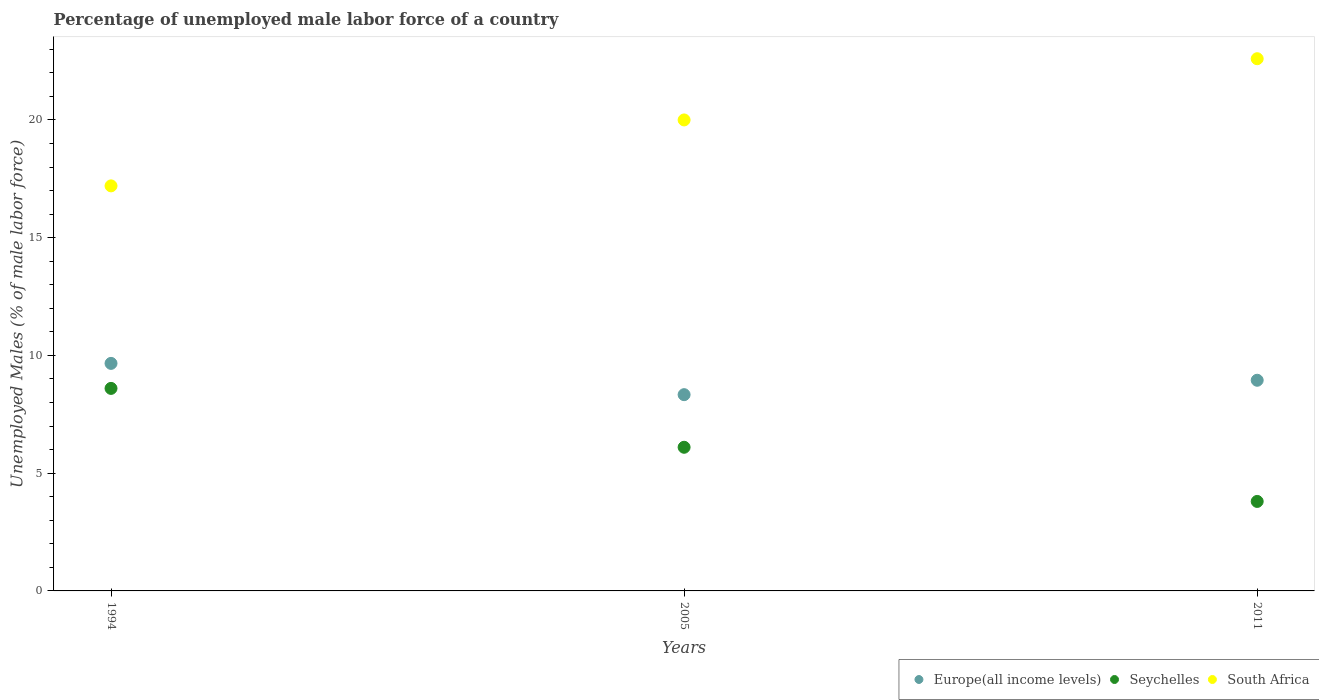How many different coloured dotlines are there?
Offer a very short reply. 3. Is the number of dotlines equal to the number of legend labels?
Your answer should be very brief. Yes. What is the percentage of unemployed male labor force in Seychelles in 2011?
Provide a short and direct response. 3.8. Across all years, what is the maximum percentage of unemployed male labor force in South Africa?
Your response must be concise. 22.6. Across all years, what is the minimum percentage of unemployed male labor force in South Africa?
Keep it short and to the point. 17.2. In which year was the percentage of unemployed male labor force in Seychelles maximum?
Your answer should be compact. 1994. In which year was the percentage of unemployed male labor force in South Africa minimum?
Provide a short and direct response. 1994. What is the total percentage of unemployed male labor force in Seychelles in the graph?
Offer a terse response. 18.5. What is the difference between the percentage of unemployed male labor force in Europe(all income levels) in 1994 and that in 2011?
Provide a short and direct response. 0.72. What is the difference between the percentage of unemployed male labor force in Seychelles in 1994 and the percentage of unemployed male labor force in Europe(all income levels) in 2005?
Provide a short and direct response. 0.27. What is the average percentage of unemployed male labor force in South Africa per year?
Make the answer very short. 19.93. In the year 1994, what is the difference between the percentage of unemployed male labor force in Seychelles and percentage of unemployed male labor force in Europe(all income levels)?
Give a very brief answer. -1.06. What is the ratio of the percentage of unemployed male labor force in South Africa in 1994 to that in 2011?
Provide a short and direct response. 0.76. Is the percentage of unemployed male labor force in Seychelles in 2005 less than that in 2011?
Your response must be concise. No. Is the difference between the percentage of unemployed male labor force in Seychelles in 1994 and 2005 greater than the difference between the percentage of unemployed male labor force in Europe(all income levels) in 1994 and 2005?
Provide a short and direct response. Yes. What is the difference between the highest and the second highest percentage of unemployed male labor force in Seychelles?
Your response must be concise. 2.5. What is the difference between the highest and the lowest percentage of unemployed male labor force in South Africa?
Provide a short and direct response. 5.4. In how many years, is the percentage of unemployed male labor force in Europe(all income levels) greater than the average percentage of unemployed male labor force in Europe(all income levels) taken over all years?
Provide a short and direct response. 1. Is the sum of the percentage of unemployed male labor force in Europe(all income levels) in 1994 and 2005 greater than the maximum percentage of unemployed male labor force in South Africa across all years?
Ensure brevity in your answer.  No. Does the percentage of unemployed male labor force in Europe(all income levels) monotonically increase over the years?
Make the answer very short. No. Is the percentage of unemployed male labor force in South Africa strictly greater than the percentage of unemployed male labor force in Europe(all income levels) over the years?
Provide a short and direct response. Yes. What is the difference between two consecutive major ticks on the Y-axis?
Keep it short and to the point. 5. Does the graph contain any zero values?
Keep it short and to the point. No. How many legend labels are there?
Ensure brevity in your answer.  3. What is the title of the graph?
Offer a terse response. Percentage of unemployed male labor force of a country. Does "Germany" appear as one of the legend labels in the graph?
Make the answer very short. No. What is the label or title of the X-axis?
Your response must be concise. Years. What is the label or title of the Y-axis?
Offer a terse response. Unemployed Males (% of male labor force). What is the Unemployed Males (% of male labor force) of Europe(all income levels) in 1994?
Your response must be concise. 9.66. What is the Unemployed Males (% of male labor force) of Seychelles in 1994?
Make the answer very short. 8.6. What is the Unemployed Males (% of male labor force) of South Africa in 1994?
Ensure brevity in your answer.  17.2. What is the Unemployed Males (% of male labor force) in Europe(all income levels) in 2005?
Your answer should be compact. 8.33. What is the Unemployed Males (% of male labor force) of Seychelles in 2005?
Keep it short and to the point. 6.1. What is the Unemployed Males (% of male labor force) of South Africa in 2005?
Keep it short and to the point. 20. What is the Unemployed Males (% of male labor force) in Europe(all income levels) in 2011?
Your answer should be very brief. 8.95. What is the Unemployed Males (% of male labor force) in Seychelles in 2011?
Make the answer very short. 3.8. What is the Unemployed Males (% of male labor force) of South Africa in 2011?
Provide a succinct answer. 22.6. Across all years, what is the maximum Unemployed Males (% of male labor force) of Europe(all income levels)?
Offer a very short reply. 9.66. Across all years, what is the maximum Unemployed Males (% of male labor force) of Seychelles?
Offer a terse response. 8.6. Across all years, what is the maximum Unemployed Males (% of male labor force) of South Africa?
Offer a very short reply. 22.6. Across all years, what is the minimum Unemployed Males (% of male labor force) in Europe(all income levels)?
Give a very brief answer. 8.33. Across all years, what is the minimum Unemployed Males (% of male labor force) of Seychelles?
Ensure brevity in your answer.  3.8. Across all years, what is the minimum Unemployed Males (% of male labor force) in South Africa?
Offer a terse response. 17.2. What is the total Unemployed Males (% of male labor force) of Europe(all income levels) in the graph?
Provide a succinct answer. 26.94. What is the total Unemployed Males (% of male labor force) of South Africa in the graph?
Ensure brevity in your answer.  59.8. What is the difference between the Unemployed Males (% of male labor force) in Europe(all income levels) in 1994 and that in 2005?
Keep it short and to the point. 1.33. What is the difference between the Unemployed Males (% of male labor force) in Europe(all income levels) in 1994 and that in 2011?
Offer a very short reply. 0.72. What is the difference between the Unemployed Males (% of male labor force) of South Africa in 1994 and that in 2011?
Give a very brief answer. -5.4. What is the difference between the Unemployed Males (% of male labor force) of Europe(all income levels) in 2005 and that in 2011?
Offer a terse response. -0.61. What is the difference between the Unemployed Males (% of male labor force) in Seychelles in 2005 and that in 2011?
Offer a terse response. 2.3. What is the difference between the Unemployed Males (% of male labor force) of South Africa in 2005 and that in 2011?
Offer a very short reply. -2.6. What is the difference between the Unemployed Males (% of male labor force) in Europe(all income levels) in 1994 and the Unemployed Males (% of male labor force) in Seychelles in 2005?
Ensure brevity in your answer.  3.56. What is the difference between the Unemployed Males (% of male labor force) of Europe(all income levels) in 1994 and the Unemployed Males (% of male labor force) of South Africa in 2005?
Offer a terse response. -10.34. What is the difference between the Unemployed Males (% of male labor force) in Europe(all income levels) in 1994 and the Unemployed Males (% of male labor force) in Seychelles in 2011?
Your answer should be very brief. 5.86. What is the difference between the Unemployed Males (% of male labor force) in Europe(all income levels) in 1994 and the Unemployed Males (% of male labor force) in South Africa in 2011?
Give a very brief answer. -12.94. What is the difference between the Unemployed Males (% of male labor force) of Seychelles in 1994 and the Unemployed Males (% of male labor force) of South Africa in 2011?
Your response must be concise. -14. What is the difference between the Unemployed Males (% of male labor force) of Europe(all income levels) in 2005 and the Unemployed Males (% of male labor force) of Seychelles in 2011?
Your answer should be compact. 4.53. What is the difference between the Unemployed Males (% of male labor force) of Europe(all income levels) in 2005 and the Unemployed Males (% of male labor force) of South Africa in 2011?
Offer a terse response. -14.27. What is the difference between the Unemployed Males (% of male labor force) of Seychelles in 2005 and the Unemployed Males (% of male labor force) of South Africa in 2011?
Provide a short and direct response. -16.5. What is the average Unemployed Males (% of male labor force) in Europe(all income levels) per year?
Ensure brevity in your answer.  8.98. What is the average Unemployed Males (% of male labor force) of Seychelles per year?
Make the answer very short. 6.17. What is the average Unemployed Males (% of male labor force) in South Africa per year?
Ensure brevity in your answer.  19.93. In the year 1994, what is the difference between the Unemployed Males (% of male labor force) in Europe(all income levels) and Unemployed Males (% of male labor force) in Seychelles?
Keep it short and to the point. 1.06. In the year 1994, what is the difference between the Unemployed Males (% of male labor force) of Europe(all income levels) and Unemployed Males (% of male labor force) of South Africa?
Ensure brevity in your answer.  -7.54. In the year 2005, what is the difference between the Unemployed Males (% of male labor force) in Europe(all income levels) and Unemployed Males (% of male labor force) in Seychelles?
Make the answer very short. 2.23. In the year 2005, what is the difference between the Unemployed Males (% of male labor force) of Europe(all income levels) and Unemployed Males (% of male labor force) of South Africa?
Your response must be concise. -11.67. In the year 2011, what is the difference between the Unemployed Males (% of male labor force) in Europe(all income levels) and Unemployed Males (% of male labor force) in Seychelles?
Give a very brief answer. 5.15. In the year 2011, what is the difference between the Unemployed Males (% of male labor force) of Europe(all income levels) and Unemployed Males (% of male labor force) of South Africa?
Make the answer very short. -13.65. In the year 2011, what is the difference between the Unemployed Males (% of male labor force) in Seychelles and Unemployed Males (% of male labor force) in South Africa?
Ensure brevity in your answer.  -18.8. What is the ratio of the Unemployed Males (% of male labor force) of Europe(all income levels) in 1994 to that in 2005?
Your answer should be compact. 1.16. What is the ratio of the Unemployed Males (% of male labor force) in Seychelles in 1994 to that in 2005?
Make the answer very short. 1.41. What is the ratio of the Unemployed Males (% of male labor force) in South Africa in 1994 to that in 2005?
Provide a succinct answer. 0.86. What is the ratio of the Unemployed Males (% of male labor force) in Europe(all income levels) in 1994 to that in 2011?
Give a very brief answer. 1.08. What is the ratio of the Unemployed Males (% of male labor force) in Seychelles in 1994 to that in 2011?
Ensure brevity in your answer.  2.26. What is the ratio of the Unemployed Males (% of male labor force) of South Africa in 1994 to that in 2011?
Your response must be concise. 0.76. What is the ratio of the Unemployed Males (% of male labor force) of Europe(all income levels) in 2005 to that in 2011?
Your response must be concise. 0.93. What is the ratio of the Unemployed Males (% of male labor force) in Seychelles in 2005 to that in 2011?
Your response must be concise. 1.61. What is the ratio of the Unemployed Males (% of male labor force) of South Africa in 2005 to that in 2011?
Offer a terse response. 0.89. What is the difference between the highest and the second highest Unemployed Males (% of male labor force) of Europe(all income levels)?
Provide a succinct answer. 0.72. What is the difference between the highest and the second highest Unemployed Males (% of male labor force) in Seychelles?
Your answer should be compact. 2.5. What is the difference between the highest and the lowest Unemployed Males (% of male labor force) in Europe(all income levels)?
Your answer should be very brief. 1.33. What is the difference between the highest and the lowest Unemployed Males (% of male labor force) in South Africa?
Make the answer very short. 5.4. 